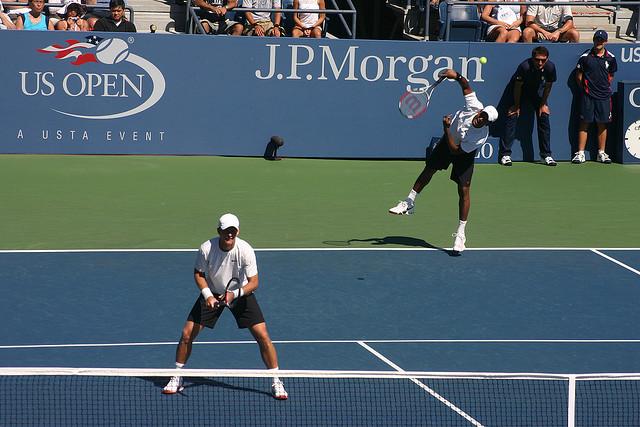Do the players have the same color hat?
Write a very short answer. Yes. How many tennis players are on the tennis court?
Quick response, please. 2. What sport are they playing?
Concise answer only. Tennis. 